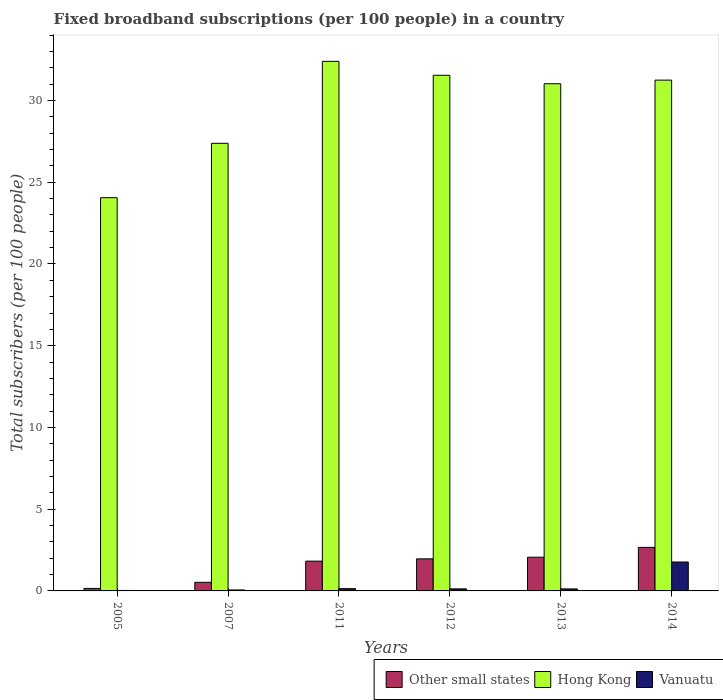How many groups of bars are there?
Provide a succinct answer. 6. Are the number of bars per tick equal to the number of legend labels?
Your answer should be very brief. Yes. What is the number of broadband subscriptions in Vanuatu in 2013?
Offer a very short reply. 0.12. Across all years, what is the maximum number of broadband subscriptions in Vanuatu?
Offer a very short reply. 1.77. Across all years, what is the minimum number of broadband subscriptions in Other small states?
Your answer should be compact. 0.15. What is the total number of broadband subscriptions in Vanuatu in the graph?
Your answer should be compact. 2.24. What is the difference between the number of broadband subscriptions in Hong Kong in 2005 and that in 2013?
Your response must be concise. -6.97. What is the difference between the number of broadband subscriptions in Other small states in 2007 and the number of broadband subscriptions in Hong Kong in 2005?
Provide a short and direct response. -23.53. What is the average number of broadband subscriptions in Other small states per year?
Ensure brevity in your answer.  1.53. In the year 2007, what is the difference between the number of broadband subscriptions in Vanuatu and number of broadband subscriptions in Hong Kong?
Provide a succinct answer. -27.32. In how many years, is the number of broadband subscriptions in Hong Kong greater than 32?
Keep it short and to the point. 1. What is the ratio of the number of broadband subscriptions in Hong Kong in 2012 to that in 2014?
Ensure brevity in your answer.  1.01. Is the number of broadband subscriptions in Hong Kong in 2005 less than that in 2007?
Offer a terse response. Yes. Is the difference between the number of broadband subscriptions in Vanuatu in 2005 and 2011 greater than the difference between the number of broadband subscriptions in Hong Kong in 2005 and 2011?
Provide a short and direct response. Yes. What is the difference between the highest and the second highest number of broadband subscriptions in Vanuatu?
Give a very brief answer. 1.63. What is the difference between the highest and the lowest number of broadband subscriptions in Other small states?
Your answer should be very brief. 2.51. Is the sum of the number of broadband subscriptions in Vanuatu in 2011 and 2012 greater than the maximum number of broadband subscriptions in Other small states across all years?
Ensure brevity in your answer.  No. What does the 1st bar from the left in 2012 represents?
Your response must be concise. Other small states. What does the 1st bar from the right in 2005 represents?
Provide a short and direct response. Vanuatu. Are all the bars in the graph horizontal?
Make the answer very short. No. How many years are there in the graph?
Provide a short and direct response. 6. Are the values on the major ticks of Y-axis written in scientific E-notation?
Give a very brief answer. No. Does the graph contain grids?
Your answer should be compact. No. Where does the legend appear in the graph?
Ensure brevity in your answer.  Bottom right. How many legend labels are there?
Offer a very short reply. 3. How are the legend labels stacked?
Provide a short and direct response. Horizontal. What is the title of the graph?
Ensure brevity in your answer.  Fixed broadband subscriptions (per 100 people) in a country. What is the label or title of the Y-axis?
Your answer should be very brief. Total subscribers (per 100 people). What is the Total subscribers (per 100 people) in Other small states in 2005?
Offer a terse response. 0.15. What is the Total subscribers (per 100 people) in Hong Kong in 2005?
Keep it short and to the point. 24.06. What is the Total subscribers (per 100 people) of Vanuatu in 2005?
Provide a short and direct response. 0.03. What is the Total subscribers (per 100 people) in Other small states in 2007?
Provide a succinct answer. 0.53. What is the Total subscribers (per 100 people) in Hong Kong in 2007?
Your answer should be compact. 27.38. What is the Total subscribers (per 100 people) in Vanuatu in 2007?
Your response must be concise. 0.06. What is the Total subscribers (per 100 people) of Other small states in 2011?
Give a very brief answer. 1.82. What is the Total subscribers (per 100 people) in Hong Kong in 2011?
Offer a terse response. 32.4. What is the Total subscribers (per 100 people) of Vanuatu in 2011?
Offer a very short reply. 0.14. What is the Total subscribers (per 100 people) in Other small states in 2012?
Ensure brevity in your answer.  1.96. What is the Total subscribers (per 100 people) in Hong Kong in 2012?
Offer a very short reply. 31.55. What is the Total subscribers (per 100 people) in Vanuatu in 2012?
Provide a short and direct response. 0.13. What is the Total subscribers (per 100 people) of Other small states in 2013?
Give a very brief answer. 2.06. What is the Total subscribers (per 100 people) in Hong Kong in 2013?
Offer a very short reply. 31.03. What is the Total subscribers (per 100 people) of Vanuatu in 2013?
Keep it short and to the point. 0.12. What is the Total subscribers (per 100 people) in Other small states in 2014?
Offer a terse response. 2.66. What is the Total subscribers (per 100 people) of Hong Kong in 2014?
Provide a succinct answer. 31.25. What is the Total subscribers (per 100 people) in Vanuatu in 2014?
Make the answer very short. 1.77. Across all years, what is the maximum Total subscribers (per 100 people) in Other small states?
Ensure brevity in your answer.  2.66. Across all years, what is the maximum Total subscribers (per 100 people) of Hong Kong?
Provide a succinct answer. 32.4. Across all years, what is the maximum Total subscribers (per 100 people) in Vanuatu?
Your answer should be compact. 1.77. Across all years, what is the minimum Total subscribers (per 100 people) of Other small states?
Keep it short and to the point. 0.15. Across all years, what is the minimum Total subscribers (per 100 people) in Hong Kong?
Provide a short and direct response. 24.06. Across all years, what is the minimum Total subscribers (per 100 people) in Vanuatu?
Your response must be concise. 0.03. What is the total Total subscribers (per 100 people) in Other small states in the graph?
Ensure brevity in your answer.  9.19. What is the total Total subscribers (per 100 people) in Hong Kong in the graph?
Your answer should be compact. 177.66. What is the total Total subscribers (per 100 people) in Vanuatu in the graph?
Your response must be concise. 2.24. What is the difference between the Total subscribers (per 100 people) of Other small states in 2005 and that in 2007?
Make the answer very short. -0.37. What is the difference between the Total subscribers (per 100 people) of Hong Kong in 2005 and that in 2007?
Make the answer very short. -3.33. What is the difference between the Total subscribers (per 100 people) of Vanuatu in 2005 and that in 2007?
Make the answer very short. -0.03. What is the difference between the Total subscribers (per 100 people) in Other small states in 2005 and that in 2011?
Your response must be concise. -1.67. What is the difference between the Total subscribers (per 100 people) of Hong Kong in 2005 and that in 2011?
Give a very brief answer. -8.34. What is the difference between the Total subscribers (per 100 people) of Vanuatu in 2005 and that in 2011?
Your answer should be very brief. -0.11. What is the difference between the Total subscribers (per 100 people) in Other small states in 2005 and that in 2012?
Your response must be concise. -1.81. What is the difference between the Total subscribers (per 100 people) of Hong Kong in 2005 and that in 2012?
Provide a succinct answer. -7.49. What is the difference between the Total subscribers (per 100 people) in Vanuatu in 2005 and that in 2012?
Make the answer very short. -0.1. What is the difference between the Total subscribers (per 100 people) of Other small states in 2005 and that in 2013?
Keep it short and to the point. -1.91. What is the difference between the Total subscribers (per 100 people) in Hong Kong in 2005 and that in 2013?
Your answer should be compact. -6.97. What is the difference between the Total subscribers (per 100 people) of Vanuatu in 2005 and that in 2013?
Your response must be concise. -0.09. What is the difference between the Total subscribers (per 100 people) in Other small states in 2005 and that in 2014?
Your answer should be very brief. -2.51. What is the difference between the Total subscribers (per 100 people) of Hong Kong in 2005 and that in 2014?
Your response must be concise. -7.19. What is the difference between the Total subscribers (per 100 people) of Vanuatu in 2005 and that in 2014?
Keep it short and to the point. -1.74. What is the difference between the Total subscribers (per 100 people) of Other small states in 2007 and that in 2011?
Your answer should be compact. -1.29. What is the difference between the Total subscribers (per 100 people) of Hong Kong in 2007 and that in 2011?
Offer a very short reply. -5.01. What is the difference between the Total subscribers (per 100 people) of Vanuatu in 2007 and that in 2011?
Provide a succinct answer. -0.08. What is the difference between the Total subscribers (per 100 people) in Other small states in 2007 and that in 2012?
Give a very brief answer. -1.44. What is the difference between the Total subscribers (per 100 people) of Hong Kong in 2007 and that in 2012?
Provide a short and direct response. -4.16. What is the difference between the Total subscribers (per 100 people) of Vanuatu in 2007 and that in 2012?
Provide a succinct answer. -0.07. What is the difference between the Total subscribers (per 100 people) of Other small states in 2007 and that in 2013?
Ensure brevity in your answer.  -1.54. What is the difference between the Total subscribers (per 100 people) in Hong Kong in 2007 and that in 2013?
Provide a short and direct response. -3.65. What is the difference between the Total subscribers (per 100 people) of Vanuatu in 2007 and that in 2013?
Offer a terse response. -0.06. What is the difference between the Total subscribers (per 100 people) of Other small states in 2007 and that in 2014?
Offer a very short reply. -2.14. What is the difference between the Total subscribers (per 100 people) in Hong Kong in 2007 and that in 2014?
Your answer should be compact. -3.87. What is the difference between the Total subscribers (per 100 people) in Vanuatu in 2007 and that in 2014?
Keep it short and to the point. -1.71. What is the difference between the Total subscribers (per 100 people) in Other small states in 2011 and that in 2012?
Your answer should be very brief. -0.14. What is the difference between the Total subscribers (per 100 people) of Hong Kong in 2011 and that in 2012?
Offer a terse response. 0.85. What is the difference between the Total subscribers (per 100 people) of Vanuatu in 2011 and that in 2012?
Keep it short and to the point. 0.01. What is the difference between the Total subscribers (per 100 people) in Other small states in 2011 and that in 2013?
Provide a short and direct response. -0.24. What is the difference between the Total subscribers (per 100 people) in Hong Kong in 2011 and that in 2013?
Your response must be concise. 1.37. What is the difference between the Total subscribers (per 100 people) of Vanuatu in 2011 and that in 2013?
Keep it short and to the point. 0.02. What is the difference between the Total subscribers (per 100 people) of Other small states in 2011 and that in 2014?
Give a very brief answer. -0.84. What is the difference between the Total subscribers (per 100 people) in Hong Kong in 2011 and that in 2014?
Keep it short and to the point. 1.15. What is the difference between the Total subscribers (per 100 people) in Vanuatu in 2011 and that in 2014?
Your answer should be compact. -1.63. What is the difference between the Total subscribers (per 100 people) in Other small states in 2012 and that in 2013?
Your answer should be compact. -0.1. What is the difference between the Total subscribers (per 100 people) in Hong Kong in 2012 and that in 2013?
Provide a succinct answer. 0.52. What is the difference between the Total subscribers (per 100 people) of Vanuatu in 2012 and that in 2013?
Make the answer very short. 0. What is the difference between the Total subscribers (per 100 people) of Other small states in 2012 and that in 2014?
Offer a very short reply. -0.7. What is the difference between the Total subscribers (per 100 people) in Hong Kong in 2012 and that in 2014?
Provide a succinct answer. 0.3. What is the difference between the Total subscribers (per 100 people) in Vanuatu in 2012 and that in 2014?
Provide a short and direct response. -1.64. What is the difference between the Total subscribers (per 100 people) of Other small states in 2013 and that in 2014?
Your answer should be compact. -0.6. What is the difference between the Total subscribers (per 100 people) of Hong Kong in 2013 and that in 2014?
Make the answer very short. -0.22. What is the difference between the Total subscribers (per 100 people) of Vanuatu in 2013 and that in 2014?
Provide a succinct answer. -1.65. What is the difference between the Total subscribers (per 100 people) of Other small states in 2005 and the Total subscribers (per 100 people) of Hong Kong in 2007?
Provide a succinct answer. -27.23. What is the difference between the Total subscribers (per 100 people) in Other small states in 2005 and the Total subscribers (per 100 people) in Vanuatu in 2007?
Provide a short and direct response. 0.09. What is the difference between the Total subscribers (per 100 people) in Hong Kong in 2005 and the Total subscribers (per 100 people) in Vanuatu in 2007?
Give a very brief answer. 24. What is the difference between the Total subscribers (per 100 people) in Other small states in 2005 and the Total subscribers (per 100 people) in Hong Kong in 2011?
Keep it short and to the point. -32.24. What is the difference between the Total subscribers (per 100 people) of Other small states in 2005 and the Total subscribers (per 100 people) of Vanuatu in 2011?
Offer a very short reply. 0.01. What is the difference between the Total subscribers (per 100 people) of Hong Kong in 2005 and the Total subscribers (per 100 people) of Vanuatu in 2011?
Your answer should be very brief. 23.92. What is the difference between the Total subscribers (per 100 people) in Other small states in 2005 and the Total subscribers (per 100 people) in Hong Kong in 2012?
Provide a short and direct response. -31.39. What is the difference between the Total subscribers (per 100 people) in Other small states in 2005 and the Total subscribers (per 100 people) in Vanuatu in 2012?
Make the answer very short. 0.03. What is the difference between the Total subscribers (per 100 people) in Hong Kong in 2005 and the Total subscribers (per 100 people) in Vanuatu in 2012?
Your answer should be very brief. 23.93. What is the difference between the Total subscribers (per 100 people) of Other small states in 2005 and the Total subscribers (per 100 people) of Hong Kong in 2013?
Your answer should be very brief. -30.88. What is the difference between the Total subscribers (per 100 people) in Other small states in 2005 and the Total subscribers (per 100 people) in Vanuatu in 2013?
Offer a terse response. 0.03. What is the difference between the Total subscribers (per 100 people) of Hong Kong in 2005 and the Total subscribers (per 100 people) of Vanuatu in 2013?
Provide a succinct answer. 23.93. What is the difference between the Total subscribers (per 100 people) of Other small states in 2005 and the Total subscribers (per 100 people) of Hong Kong in 2014?
Your response must be concise. -31.1. What is the difference between the Total subscribers (per 100 people) of Other small states in 2005 and the Total subscribers (per 100 people) of Vanuatu in 2014?
Give a very brief answer. -1.62. What is the difference between the Total subscribers (per 100 people) in Hong Kong in 2005 and the Total subscribers (per 100 people) in Vanuatu in 2014?
Your answer should be compact. 22.29. What is the difference between the Total subscribers (per 100 people) in Other small states in 2007 and the Total subscribers (per 100 people) in Hong Kong in 2011?
Keep it short and to the point. -31.87. What is the difference between the Total subscribers (per 100 people) of Other small states in 2007 and the Total subscribers (per 100 people) of Vanuatu in 2011?
Offer a terse response. 0.39. What is the difference between the Total subscribers (per 100 people) in Hong Kong in 2007 and the Total subscribers (per 100 people) in Vanuatu in 2011?
Make the answer very short. 27.24. What is the difference between the Total subscribers (per 100 people) of Other small states in 2007 and the Total subscribers (per 100 people) of Hong Kong in 2012?
Provide a short and direct response. -31.02. What is the difference between the Total subscribers (per 100 people) in Other small states in 2007 and the Total subscribers (per 100 people) in Vanuatu in 2012?
Ensure brevity in your answer.  0.4. What is the difference between the Total subscribers (per 100 people) of Hong Kong in 2007 and the Total subscribers (per 100 people) of Vanuatu in 2012?
Offer a terse response. 27.26. What is the difference between the Total subscribers (per 100 people) in Other small states in 2007 and the Total subscribers (per 100 people) in Hong Kong in 2013?
Ensure brevity in your answer.  -30.5. What is the difference between the Total subscribers (per 100 people) of Other small states in 2007 and the Total subscribers (per 100 people) of Vanuatu in 2013?
Offer a very short reply. 0.4. What is the difference between the Total subscribers (per 100 people) of Hong Kong in 2007 and the Total subscribers (per 100 people) of Vanuatu in 2013?
Your answer should be compact. 27.26. What is the difference between the Total subscribers (per 100 people) of Other small states in 2007 and the Total subscribers (per 100 people) of Hong Kong in 2014?
Ensure brevity in your answer.  -30.72. What is the difference between the Total subscribers (per 100 people) in Other small states in 2007 and the Total subscribers (per 100 people) in Vanuatu in 2014?
Your answer should be very brief. -1.24. What is the difference between the Total subscribers (per 100 people) in Hong Kong in 2007 and the Total subscribers (per 100 people) in Vanuatu in 2014?
Provide a short and direct response. 25.61. What is the difference between the Total subscribers (per 100 people) of Other small states in 2011 and the Total subscribers (per 100 people) of Hong Kong in 2012?
Give a very brief answer. -29.72. What is the difference between the Total subscribers (per 100 people) of Other small states in 2011 and the Total subscribers (per 100 people) of Vanuatu in 2012?
Offer a terse response. 1.7. What is the difference between the Total subscribers (per 100 people) of Hong Kong in 2011 and the Total subscribers (per 100 people) of Vanuatu in 2012?
Offer a very short reply. 32.27. What is the difference between the Total subscribers (per 100 people) of Other small states in 2011 and the Total subscribers (per 100 people) of Hong Kong in 2013?
Keep it short and to the point. -29.21. What is the difference between the Total subscribers (per 100 people) in Other small states in 2011 and the Total subscribers (per 100 people) in Vanuatu in 2013?
Keep it short and to the point. 1.7. What is the difference between the Total subscribers (per 100 people) in Hong Kong in 2011 and the Total subscribers (per 100 people) in Vanuatu in 2013?
Your response must be concise. 32.27. What is the difference between the Total subscribers (per 100 people) of Other small states in 2011 and the Total subscribers (per 100 people) of Hong Kong in 2014?
Offer a very short reply. -29.43. What is the difference between the Total subscribers (per 100 people) in Other small states in 2011 and the Total subscribers (per 100 people) in Vanuatu in 2014?
Make the answer very short. 0.05. What is the difference between the Total subscribers (per 100 people) of Hong Kong in 2011 and the Total subscribers (per 100 people) of Vanuatu in 2014?
Provide a succinct answer. 30.63. What is the difference between the Total subscribers (per 100 people) of Other small states in 2012 and the Total subscribers (per 100 people) of Hong Kong in 2013?
Your answer should be very brief. -29.07. What is the difference between the Total subscribers (per 100 people) in Other small states in 2012 and the Total subscribers (per 100 people) in Vanuatu in 2013?
Ensure brevity in your answer.  1.84. What is the difference between the Total subscribers (per 100 people) of Hong Kong in 2012 and the Total subscribers (per 100 people) of Vanuatu in 2013?
Make the answer very short. 31.42. What is the difference between the Total subscribers (per 100 people) of Other small states in 2012 and the Total subscribers (per 100 people) of Hong Kong in 2014?
Your response must be concise. -29.29. What is the difference between the Total subscribers (per 100 people) of Other small states in 2012 and the Total subscribers (per 100 people) of Vanuatu in 2014?
Provide a short and direct response. 0.19. What is the difference between the Total subscribers (per 100 people) of Hong Kong in 2012 and the Total subscribers (per 100 people) of Vanuatu in 2014?
Make the answer very short. 29.78. What is the difference between the Total subscribers (per 100 people) of Other small states in 2013 and the Total subscribers (per 100 people) of Hong Kong in 2014?
Your response must be concise. -29.19. What is the difference between the Total subscribers (per 100 people) in Other small states in 2013 and the Total subscribers (per 100 people) in Vanuatu in 2014?
Ensure brevity in your answer.  0.29. What is the difference between the Total subscribers (per 100 people) of Hong Kong in 2013 and the Total subscribers (per 100 people) of Vanuatu in 2014?
Ensure brevity in your answer.  29.26. What is the average Total subscribers (per 100 people) in Other small states per year?
Give a very brief answer. 1.53. What is the average Total subscribers (per 100 people) of Hong Kong per year?
Keep it short and to the point. 29.61. What is the average Total subscribers (per 100 people) of Vanuatu per year?
Provide a succinct answer. 0.37. In the year 2005, what is the difference between the Total subscribers (per 100 people) in Other small states and Total subscribers (per 100 people) in Hong Kong?
Offer a terse response. -23.9. In the year 2005, what is the difference between the Total subscribers (per 100 people) in Other small states and Total subscribers (per 100 people) in Vanuatu?
Keep it short and to the point. 0.12. In the year 2005, what is the difference between the Total subscribers (per 100 people) in Hong Kong and Total subscribers (per 100 people) in Vanuatu?
Ensure brevity in your answer.  24.03. In the year 2007, what is the difference between the Total subscribers (per 100 people) of Other small states and Total subscribers (per 100 people) of Hong Kong?
Your answer should be very brief. -26.86. In the year 2007, what is the difference between the Total subscribers (per 100 people) of Other small states and Total subscribers (per 100 people) of Vanuatu?
Give a very brief answer. 0.47. In the year 2007, what is the difference between the Total subscribers (per 100 people) of Hong Kong and Total subscribers (per 100 people) of Vanuatu?
Give a very brief answer. 27.32. In the year 2011, what is the difference between the Total subscribers (per 100 people) of Other small states and Total subscribers (per 100 people) of Hong Kong?
Your answer should be compact. -30.58. In the year 2011, what is the difference between the Total subscribers (per 100 people) of Other small states and Total subscribers (per 100 people) of Vanuatu?
Make the answer very short. 1.68. In the year 2011, what is the difference between the Total subscribers (per 100 people) of Hong Kong and Total subscribers (per 100 people) of Vanuatu?
Provide a succinct answer. 32.26. In the year 2012, what is the difference between the Total subscribers (per 100 people) in Other small states and Total subscribers (per 100 people) in Hong Kong?
Keep it short and to the point. -29.58. In the year 2012, what is the difference between the Total subscribers (per 100 people) of Other small states and Total subscribers (per 100 people) of Vanuatu?
Provide a succinct answer. 1.84. In the year 2012, what is the difference between the Total subscribers (per 100 people) of Hong Kong and Total subscribers (per 100 people) of Vanuatu?
Your answer should be very brief. 31.42. In the year 2013, what is the difference between the Total subscribers (per 100 people) of Other small states and Total subscribers (per 100 people) of Hong Kong?
Ensure brevity in your answer.  -28.97. In the year 2013, what is the difference between the Total subscribers (per 100 people) of Other small states and Total subscribers (per 100 people) of Vanuatu?
Your answer should be very brief. 1.94. In the year 2013, what is the difference between the Total subscribers (per 100 people) in Hong Kong and Total subscribers (per 100 people) in Vanuatu?
Your answer should be compact. 30.91. In the year 2014, what is the difference between the Total subscribers (per 100 people) in Other small states and Total subscribers (per 100 people) in Hong Kong?
Offer a very short reply. -28.59. In the year 2014, what is the difference between the Total subscribers (per 100 people) of Other small states and Total subscribers (per 100 people) of Vanuatu?
Your answer should be compact. 0.89. In the year 2014, what is the difference between the Total subscribers (per 100 people) of Hong Kong and Total subscribers (per 100 people) of Vanuatu?
Give a very brief answer. 29.48. What is the ratio of the Total subscribers (per 100 people) in Other small states in 2005 to that in 2007?
Your response must be concise. 0.29. What is the ratio of the Total subscribers (per 100 people) in Hong Kong in 2005 to that in 2007?
Give a very brief answer. 0.88. What is the ratio of the Total subscribers (per 100 people) in Vanuatu in 2005 to that in 2007?
Offer a very short reply. 0.48. What is the ratio of the Total subscribers (per 100 people) of Other small states in 2005 to that in 2011?
Your answer should be very brief. 0.08. What is the ratio of the Total subscribers (per 100 people) of Hong Kong in 2005 to that in 2011?
Offer a very short reply. 0.74. What is the ratio of the Total subscribers (per 100 people) in Vanuatu in 2005 to that in 2011?
Keep it short and to the point. 0.2. What is the ratio of the Total subscribers (per 100 people) of Other small states in 2005 to that in 2012?
Your answer should be compact. 0.08. What is the ratio of the Total subscribers (per 100 people) in Hong Kong in 2005 to that in 2012?
Your response must be concise. 0.76. What is the ratio of the Total subscribers (per 100 people) in Vanuatu in 2005 to that in 2012?
Provide a succinct answer. 0.22. What is the ratio of the Total subscribers (per 100 people) in Other small states in 2005 to that in 2013?
Make the answer very short. 0.07. What is the ratio of the Total subscribers (per 100 people) in Hong Kong in 2005 to that in 2013?
Your answer should be compact. 0.78. What is the ratio of the Total subscribers (per 100 people) of Vanuatu in 2005 to that in 2013?
Give a very brief answer. 0.23. What is the ratio of the Total subscribers (per 100 people) of Other small states in 2005 to that in 2014?
Keep it short and to the point. 0.06. What is the ratio of the Total subscribers (per 100 people) in Hong Kong in 2005 to that in 2014?
Offer a terse response. 0.77. What is the ratio of the Total subscribers (per 100 people) of Vanuatu in 2005 to that in 2014?
Offer a terse response. 0.02. What is the ratio of the Total subscribers (per 100 people) of Other small states in 2007 to that in 2011?
Offer a terse response. 0.29. What is the ratio of the Total subscribers (per 100 people) of Hong Kong in 2007 to that in 2011?
Provide a succinct answer. 0.85. What is the ratio of the Total subscribers (per 100 people) in Vanuatu in 2007 to that in 2011?
Your response must be concise. 0.42. What is the ratio of the Total subscribers (per 100 people) in Other small states in 2007 to that in 2012?
Keep it short and to the point. 0.27. What is the ratio of the Total subscribers (per 100 people) in Hong Kong in 2007 to that in 2012?
Make the answer very short. 0.87. What is the ratio of the Total subscribers (per 100 people) of Vanuatu in 2007 to that in 2012?
Give a very brief answer. 0.47. What is the ratio of the Total subscribers (per 100 people) of Other small states in 2007 to that in 2013?
Offer a very short reply. 0.26. What is the ratio of the Total subscribers (per 100 people) of Hong Kong in 2007 to that in 2013?
Your response must be concise. 0.88. What is the ratio of the Total subscribers (per 100 people) of Vanuatu in 2007 to that in 2013?
Provide a short and direct response. 0.48. What is the ratio of the Total subscribers (per 100 people) of Other small states in 2007 to that in 2014?
Keep it short and to the point. 0.2. What is the ratio of the Total subscribers (per 100 people) in Hong Kong in 2007 to that in 2014?
Your answer should be compact. 0.88. What is the ratio of the Total subscribers (per 100 people) in Vanuatu in 2007 to that in 2014?
Offer a terse response. 0.03. What is the ratio of the Total subscribers (per 100 people) of Other small states in 2011 to that in 2012?
Your answer should be very brief. 0.93. What is the ratio of the Total subscribers (per 100 people) in Vanuatu in 2011 to that in 2012?
Provide a succinct answer. 1.11. What is the ratio of the Total subscribers (per 100 people) in Other small states in 2011 to that in 2013?
Offer a terse response. 0.88. What is the ratio of the Total subscribers (per 100 people) in Hong Kong in 2011 to that in 2013?
Your response must be concise. 1.04. What is the ratio of the Total subscribers (per 100 people) of Vanuatu in 2011 to that in 2013?
Ensure brevity in your answer.  1.14. What is the ratio of the Total subscribers (per 100 people) in Other small states in 2011 to that in 2014?
Ensure brevity in your answer.  0.68. What is the ratio of the Total subscribers (per 100 people) of Hong Kong in 2011 to that in 2014?
Offer a terse response. 1.04. What is the ratio of the Total subscribers (per 100 people) of Vanuatu in 2011 to that in 2014?
Give a very brief answer. 0.08. What is the ratio of the Total subscribers (per 100 people) in Other small states in 2012 to that in 2013?
Offer a very short reply. 0.95. What is the ratio of the Total subscribers (per 100 people) of Hong Kong in 2012 to that in 2013?
Your response must be concise. 1.02. What is the ratio of the Total subscribers (per 100 people) in Vanuatu in 2012 to that in 2013?
Provide a succinct answer. 1.02. What is the ratio of the Total subscribers (per 100 people) in Other small states in 2012 to that in 2014?
Make the answer very short. 0.74. What is the ratio of the Total subscribers (per 100 people) in Hong Kong in 2012 to that in 2014?
Give a very brief answer. 1.01. What is the ratio of the Total subscribers (per 100 people) of Vanuatu in 2012 to that in 2014?
Ensure brevity in your answer.  0.07. What is the ratio of the Total subscribers (per 100 people) of Other small states in 2013 to that in 2014?
Offer a terse response. 0.77. What is the ratio of the Total subscribers (per 100 people) of Vanuatu in 2013 to that in 2014?
Offer a terse response. 0.07. What is the difference between the highest and the second highest Total subscribers (per 100 people) in Other small states?
Your answer should be compact. 0.6. What is the difference between the highest and the second highest Total subscribers (per 100 people) of Hong Kong?
Your answer should be very brief. 0.85. What is the difference between the highest and the second highest Total subscribers (per 100 people) of Vanuatu?
Ensure brevity in your answer.  1.63. What is the difference between the highest and the lowest Total subscribers (per 100 people) of Other small states?
Offer a very short reply. 2.51. What is the difference between the highest and the lowest Total subscribers (per 100 people) of Hong Kong?
Provide a short and direct response. 8.34. What is the difference between the highest and the lowest Total subscribers (per 100 people) in Vanuatu?
Provide a short and direct response. 1.74. 